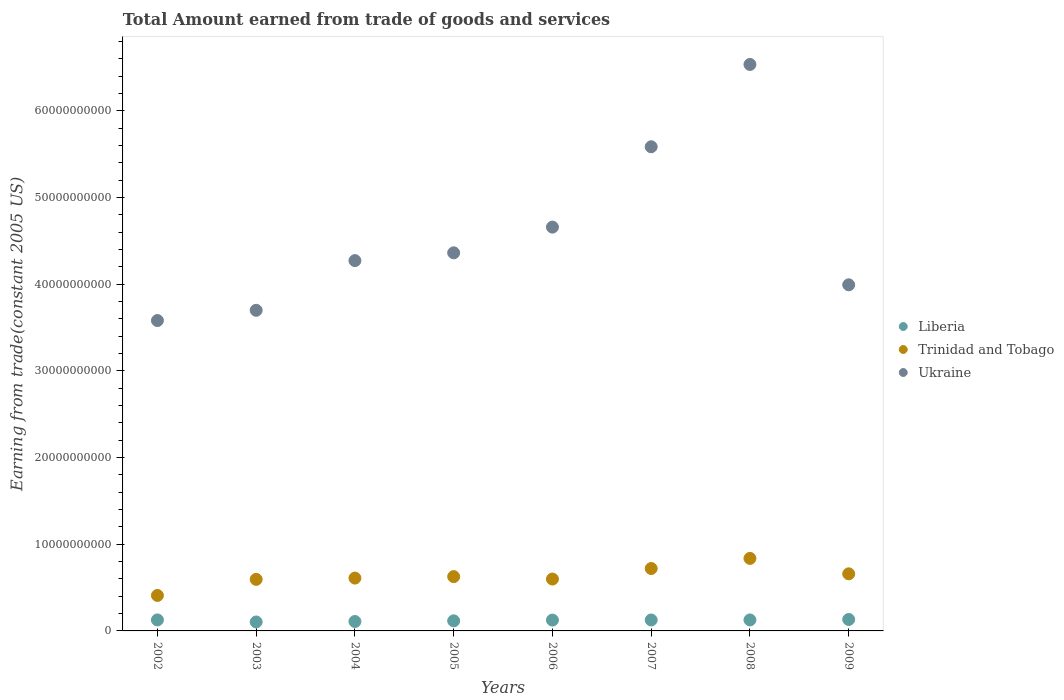Is the number of dotlines equal to the number of legend labels?
Keep it short and to the point. Yes. What is the total amount earned by trading goods and services in Trinidad and Tobago in 2009?
Offer a very short reply. 6.59e+09. Across all years, what is the maximum total amount earned by trading goods and services in Liberia?
Provide a short and direct response. 1.32e+09. Across all years, what is the minimum total amount earned by trading goods and services in Liberia?
Your answer should be compact. 1.03e+09. In which year was the total amount earned by trading goods and services in Liberia maximum?
Offer a terse response. 2009. In which year was the total amount earned by trading goods and services in Liberia minimum?
Ensure brevity in your answer.  2003. What is the total total amount earned by trading goods and services in Trinidad and Tobago in the graph?
Your answer should be very brief. 5.05e+1. What is the difference between the total amount earned by trading goods and services in Trinidad and Tobago in 2005 and that in 2007?
Your response must be concise. -9.33e+08. What is the difference between the total amount earned by trading goods and services in Trinidad and Tobago in 2005 and the total amount earned by trading goods and services in Liberia in 2009?
Ensure brevity in your answer.  4.94e+09. What is the average total amount earned by trading goods and services in Liberia per year?
Provide a short and direct response. 1.21e+09. In the year 2009, what is the difference between the total amount earned by trading goods and services in Ukraine and total amount earned by trading goods and services in Liberia?
Give a very brief answer. 3.86e+1. In how many years, is the total amount earned by trading goods and services in Liberia greater than 64000000000 US$?
Give a very brief answer. 0. What is the ratio of the total amount earned by trading goods and services in Trinidad and Tobago in 2006 to that in 2009?
Provide a short and direct response. 0.91. What is the difference between the highest and the second highest total amount earned by trading goods and services in Liberia?
Your response must be concise. 5.17e+07. What is the difference between the highest and the lowest total amount earned by trading goods and services in Liberia?
Make the answer very short. 2.88e+08. Does the total amount earned by trading goods and services in Ukraine monotonically increase over the years?
Provide a short and direct response. No. Is the total amount earned by trading goods and services in Trinidad and Tobago strictly greater than the total amount earned by trading goods and services in Liberia over the years?
Ensure brevity in your answer.  Yes. How many dotlines are there?
Provide a succinct answer. 3. Are the values on the major ticks of Y-axis written in scientific E-notation?
Ensure brevity in your answer.  No. Where does the legend appear in the graph?
Your answer should be very brief. Center right. How many legend labels are there?
Give a very brief answer. 3. How are the legend labels stacked?
Your response must be concise. Vertical. What is the title of the graph?
Your answer should be very brief. Total Amount earned from trade of goods and services. Does "Latin America(all income levels)" appear as one of the legend labels in the graph?
Give a very brief answer. No. What is the label or title of the X-axis?
Ensure brevity in your answer.  Years. What is the label or title of the Y-axis?
Offer a terse response. Earning from trade(constant 2005 US). What is the Earning from trade(constant 2005 US) of Liberia in 2002?
Make the answer very short. 1.27e+09. What is the Earning from trade(constant 2005 US) in Trinidad and Tobago in 2002?
Your response must be concise. 4.09e+09. What is the Earning from trade(constant 2005 US) of Ukraine in 2002?
Your answer should be very brief. 3.58e+1. What is the Earning from trade(constant 2005 US) of Liberia in 2003?
Your response must be concise. 1.03e+09. What is the Earning from trade(constant 2005 US) of Trinidad and Tobago in 2003?
Keep it short and to the point. 5.95e+09. What is the Earning from trade(constant 2005 US) in Ukraine in 2003?
Keep it short and to the point. 3.70e+1. What is the Earning from trade(constant 2005 US) of Liberia in 2004?
Your answer should be compact. 1.09e+09. What is the Earning from trade(constant 2005 US) of Trinidad and Tobago in 2004?
Give a very brief answer. 6.10e+09. What is the Earning from trade(constant 2005 US) in Ukraine in 2004?
Make the answer very short. 4.27e+1. What is the Earning from trade(constant 2005 US) in Liberia in 2005?
Your answer should be compact. 1.16e+09. What is the Earning from trade(constant 2005 US) of Trinidad and Tobago in 2005?
Provide a succinct answer. 6.27e+09. What is the Earning from trade(constant 2005 US) in Ukraine in 2005?
Your response must be concise. 4.36e+1. What is the Earning from trade(constant 2005 US) of Liberia in 2006?
Your answer should be very brief. 1.25e+09. What is the Earning from trade(constant 2005 US) in Trinidad and Tobago in 2006?
Ensure brevity in your answer.  5.99e+09. What is the Earning from trade(constant 2005 US) of Ukraine in 2006?
Your response must be concise. 4.66e+1. What is the Earning from trade(constant 2005 US) in Liberia in 2007?
Your answer should be very brief. 1.26e+09. What is the Earning from trade(constant 2005 US) in Trinidad and Tobago in 2007?
Keep it short and to the point. 7.20e+09. What is the Earning from trade(constant 2005 US) of Ukraine in 2007?
Provide a short and direct response. 5.59e+1. What is the Earning from trade(constant 2005 US) of Liberia in 2008?
Offer a terse response. 1.27e+09. What is the Earning from trade(constant 2005 US) of Trinidad and Tobago in 2008?
Keep it short and to the point. 8.37e+09. What is the Earning from trade(constant 2005 US) in Ukraine in 2008?
Your answer should be compact. 6.54e+1. What is the Earning from trade(constant 2005 US) in Liberia in 2009?
Offer a terse response. 1.32e+09. What is the Earning from trade(constant 2005 US) in Trinidad and Tobago in 2009?
Provide a succinct answer. 6.59e+09. What is the Earning from trade(constant 2005 US) of Ukraine in 2009?
Keep it short and to the point. 3.99e+1. Across all years, what is the maximum Earning from trade(constant 2005 US) of Liberia?
Offer a very short reply. 1.32e+09. Across all years, what is the maximum Earning from trade(constant 2005 US) in Trinidad and Tobago?
Your answer should be compact. 8.37e+09. Across all years, what is the maximum Earning from trade(constant 2005 US) in Ukraine?
Your answer should be very brief. 6.54e+1. Across all years, what is the minimum Earning from trade(constant 2005 US) in Liberia?
Your answer should be compact. 1.03e+09. Across all years, what is the minimum Earning from trade(constant 2005 US) in Trinidad and Tobago?
Offer a very short reply. 4.09e+09. Across all years, what is the minimum Earning from trade(constant 2005 US) of Ukraine?
Your answer should be compact. 3.58e+1. What is the total Earning from trade(constant 2005 US) of Liberia in the graph?
Ensure brevity in your answer.  9.65e+09. What is the total Earning from trade(constant 2005 US) in Trinidad and Tobago in the graph?
Ensure brevity in your answer.  5.05e+1. What is the total Earning from trade(constant 2005 US) in Ukraine in the graph?
Keep it short and to the point. 3.67e+11. What is the difference between the Earning from trade(constant 2005 US) in Liberia in 2002 and that in 2003?
Make the answer very short. 2.36e+08. What is the difference between the Earning from trade(constant 2005 US) of Trinidad and Tobago in 2002 and that in 2003?
Offer a terse response. -1.86e+09. What is the difference between the Earning from trade(constant 2005 US) of Ukraine in 2002 and that in 2003?
Offer a very short reply. -1.18e+09. What is the difference between the Earning from trade(constant 2005 US) in Liberia in 2002 and that in 2004?
Provide a short and direct response. 1.83e+08. What is the difference between the Earning from trade(constant 2005 US) of Trinidad and Tobago in 2002 and that in 2004?
Offer a very short reply. -2.00e+09. What is the difference between the Earning from trade(constant 2005 US) in Ukraine in 2002 and that in 2004?
Your answer should be very brief. -6.92e+09. What is the difference between the Earning from trade(constant 2005 US) of Liberia in 2002 and that in 2005?
Provide a short and direct response. 1.07e+08. What is the difference between the Earning from trade(constant 2005 US) in Trinidad and Tobago in 2002 and that in 2005?
Provide a short and direct response. -2.17e+09. What is the difference between the Earning from trade(constant 2005 US) in Ukraine in 2002 and that in 2005?
Provide a short and direct response. -7.81e+09. What is the difference between the Earning from trade(constant 2005 US) of Liberia in 2002 and that in 2006?
Your answer should be compact. 1.92e+07. What is the difference between the Earning from trade(constant 2005 US) in Trinidad and Tobago in 2002 and that in 2006?
Keep it short and to the point. -1.89e+09. What is the difference between the Earning from trade(constant 2005 US) in Ukraine in 2002 and that in 2006?
Give a very brief answer. -1.08e+1. What is the difference between the Earning from trade(constant 2005 US) of Liberia in 2002 and that in 2007?
Your response must be concise. 6.13e+06. What is the difference between the Earning from trade(constant 2005 US) in Trinidad and Tobago in 2002 and that in 2007?
Ensure brevity in your answer.  -3.11e+09. What is the difference between the Earning from trade(constant 2005 US) of Ukraine in 2002 and that in 2007?
Offer a terse response. -2.01e+1. What is the difference between the Earning from trade(constant 2005 US) of Liberia in 2002 and that in 2008?
Your answer should be very brief. 1.72e+06. What is the difference between the Earning from trade(constant 2005 US) of Trinidad and Tobago in 2002 and that in 2008?
Your answer should be very brief. -4.28e+09. What is the difference between the Earning from trade(constant 2005 US) in Ukraine in 2002 and that in 2008?
Make the answer very short. -2.95e+1. What is the difference between the Earning from trade(constant 2005 US) of Liberia in 2002 and that in 2009?
Give a very brief answer. -5.17e+07. What is the difference between the Earning from trade(constant 2005 US) in Trinidad and Tobago in 2002 and that in 2009?
Keep it short and to the point. -2.49e+09. What is the difference between the Earning from trade(constant 2005 US) in Ukraine in 2002 and that in 2009?
Ensure brevity in your answer.  -4.12e+09. What is the difference between the Earning from trade(constant 2005 US) in Liberia in 2003 and that in 2004?
Keep it short and to the point. -5.36e+07. What is the difference between the Earning from trade(constant 2005 US) of Trinidad and Tobago in 2003 and that in 2004?
Your answer should be compact. -1.48e+08. What is the difference between the Earning from trade(constant 2005 US) of Ukraine in 2003 and that in 2004?
Offer a terse response. -5.73e+09. What is the difference between the Earning from trade(constant 2005 US) in Liberia in 2003 and that in 2005?
Your answer should be compact. -1.29e+08. What is the difference between the Earning from trade(constant 2005 US) of Trinidad and Tobago in 2003 and that in 2005?
Your answer should be compact. -3.18e+08. What is the difference between the Earning from trade(constant 2005 US) in Ukraine in 2003 and that in 2005?
Offer a terse response. -6.63e+09. What is the difference between the Earning from trade(constant 2005 US) in Liberia in 2003 and that in 2006?
Provide a short and direct response. -2.17e+08. What is the difference between the Earning from trade(constant 2005 US) of Trinidad and Tobago in 2003 and that in 2006?
Your answer should be compact. -3.75e+07. What is the difference between the Earning from trade(constant 2005 US) of Ukraine in 2003 and that in 2006?
Offer a very short reply. -9.60e+09. What is the difference between the Earning from trade(constant 2005 US) of Liberia in 2003 and that in 2007?
Your response must be concise. -2.30e+08. What is the difference between the Earning from trade(constant 2005 US) of Trinidad and Tobago in 2003 and that in 2007?
Your answer should be compact. -1.25e+09. What is the difference between the Earning from trade(constant 2005 US) of Ukraine in 2003 and that in 2007?
Keep it short and to the point. -1.89e+1. What is the difference between the Earning from trade(constant 2005 US) of Liberia in 2003 and that in 2008?
Provide a succinct answer. -2.34e+08. What is the difference between the Earning from trade(constant 2005 US) of Trinidad and Tobago in 2003 and that in 2008?
Offer a terse response. -2.42e+09. What is the difference between the Earning from trade(constant 2005 US) in Ukraine in 2003 and that in 2008?
Ensure brevity in your answer.  -2.84e+1. What is the difference between the Earning from trade(constant 2005 US) in Liberia in 2003 and that in 2009?
Offer a terse response. -2.88e+08. What is the difference between the Earning from trade(constant 2005 US) of Trinidad and Tobago in 2003 and that in 2009?
Offer a terse response. -6.39e+08. What is the difference between the Earning from trade(constant 2005 US) in Ukraine in 2003 and that in 2009?
Offer a very short reply. -2.94e+09. What is the difference between the Earning from trade(constant 2005 US) in Liberia in 2004 and that in 2005?
Provide a short and direct response. -7.54e+07. What is the difference between the Earning from trade(constant 2005 US) of Trinidad and Tobago in 2004 and that in 2005?
Offer a terse response. -1.70e+08. What is the difference between the Earning from trade(constant 2005 US) of Ukraine in 2004 and that in 2005?
Offer a very short reply. -8.97e+08. What is the difference between the Earning from trade(constant 2005 US) of Liberia in 2004 and that in 2006?
Make the answer very short. -1.63e+08. What is the difference between the Earning from trade(constant 2005 US) in Trinidad and Tobago in 2004 and that in 2006?
Your answer should be compact. 1.11e+08. What is the difference between the Earning from trade(constant 2005 US) of Ukraine in 2004 and that in 2006?
Provide a succinct answer. -3.86e+09. What is the difference between the Earning from trade(constant 2005 US) in Liberia in 2004 and that in 2007?
Offer a very short reply. -1.76e+08. What is the difference between the Earning from trade(constant 2005 US) in Trinidad and Tobago in 2004 and that in 2007?
Offer a terse response. -1.10e+09. What is the difference between the Earning from trade(constant 2005 US) of Ukraine in 2004 and that in 2007?
Provide a succinct answer. -1.31e+1. What is the difference between the Earning from trade(constant 2005 US) of Liberia in 2004 and that in 2008?
Give a very brief answer. -1.81e+08. What is the difference between the Earning from trade(constant 2005 US) of Trinidad and Tobago in 2004 and that in 2008?
Provide a short and direct response. -2.27e+09. What is the difference between the Earning from trade(constant 2005 US) in Ukraine in 2004 and that in 2008?
Offer a very short reply. -2.26e+1. What is the difference between the Earning from trade(constant 2005 US) in Liberia in 2004 and that in 2009?
Keep it short and to the point. -2.34e+08. What is the difference between the Earning from trade(constant 2005 US) in Trinidad and Tobago in 2004 and that in 2009?
Provide a succinct answer. -4.90e+08. What is the difference between the Earning from trade(constant 2005 US) in Ukraine in 2004 and that in 2009?
Your response must be concise. 2.79e+09. What is the difference between the Earning from trade(constant 2005 US) in Liberia in 2005 and that in 2006?
Give a very brief answer. -8.80e+07. What is the difference between the Earning from trade(constant 2005 US) of Trinidad and Tobago in 2005 and that in 2006?
Your response must be concise. 2.81e+08. What is the difference between the Earning from trade(constant 2005 US) in Ukraine in 2005 and that in 2006?
Provide a succinct answer. -2.97e+09. What is the difference between the Earning from trade(constant 2005 US) in Liberia in 2005 and that in 2007?
Make the answer very short. -1.01e+08. What is the difference between the Earning from trade(constant 2005 US) in Trinidad and Tobago in 2005 and that in 2007?
Provide a succinct answer. -9.33e+08. What is the difference between the Earning from trade(constant 2005 US) in Ukraine in 2005 and that in 2007?
Offer a terse response. -1.22e+1. What is the difference between the Earning from trade(constant 2005 US) of Liberia in 2005 and that in 2008?
Make the answer very short. -1.06e+08. What is the difference between the Earning from trade(constant 2005 US) in Trinidad and Tobago in 2005 and that in 2008?
Keep it short and to the point. -2.10e+09. What is the difference between the Earning from trade(constant 2005 US) of Ukraine in 2005 and that in 2008?
Make the answer very short. -2.17e+1. What is the difference between the Earning from trade(constant 2005 US) in Liberia in 2005 and that in 2009?
Offer a very short reply. -1.59e+08. What is the difference between the Earning from trade(constant 2005 US) of Trinidad and Tobago in 2005 and that in 2009?
Offer a terse response. -3.20e+08. What is the difference between the Earning from trade(constant 2005 US) in Ukraine in 2005 and that in 2009?
Keep it short and to the point. 3.69e+09. What is the difference between the Earning from trade(constant 2005 US) in Liberia in 2006 and that in 2007?
Provide a succinct answer. -1.31e+07. What is the difference between the Earning from trade(constant 2005 US) of Trinidad and Tobago in 2006 and that in 2007?
Your response must be concise. -1.21e+09. What is the difference between the Earning from trade(constant 2005 US) of Ukraine in 2006 and that in 2007?
Give a very brief answer. -9.27e+09. What is the difference between the Earning from trade(constant 2005 US) of Liberia in 2006 and that in 2008?
Ensure brevity in your answer.  -1.75e+07. What is the difference between the Earning from trade(constant 2005 US) of Trinidad and Tobago in 2006 and that in 2008?
Your answer should be very brief. -2.38e+09. What is the difference between the Earning from trade(constant 2005 US) of Ukraine in 2006 and that in 2008?
Provide a succinct answer. -1.88e+1. What is the difference between the Earning from trade(constant 2005 US) in Liberia in 2006 and that in 2009?
Your response must be concise. -7.09e+07. What is the difference between the Earning from trade(constant 2005 US) in Trinidad and Tobago in 2006 and that in 2009?
Provide a short and direct response. -6.01e+08. What is the difference between the Earning from trade(constant 2005 US) of Ukraine in 2006 and that in 2009?
Your answer should be compact. 6.66e+09. What is the difference between the Earning from trade(constant 2005 US) of Liberia in 2007 and that in 2008?
Make the answer very short. -4.40e+06. What is the difference between the Earning from trade(constant 2005 US) in Trinidad and Tobago in 2007 and that in 2008?
Provide a short and direct response. -1.17e+09. What is the difference between the Earning from trade(constant 2005 US) of Ukraine in 2007 and that in 2008?
Give a very brief answer. -9.50e+09. What is the difference between the Earning from trade(constant 2005 US) of Liberia in 2007 and that in 2009?
Give a very brief answer. -5.79e+07. What is the difference between the Earning from trade(constant 2005 US) in Trinidad and Tobago in 2007 and that in 2009?
Provide a succinct answer. 6.12e+08. What is the difference between the Earning from trade(constant 2005 US) of Ukraine in 2007 and that in 2009?
Your answer should be compact. 1.59e+1. What is the difference between the Earning from trade(constant 2005 US) of Liberia in 2008 and that in 2009?
Your answer should be very brief. -5.35e+07. What is the difference between the Earning from trade(constant 2005 US) in Trinidad and Tobago in 2008 and that in 2009?
Provide a short and direct response. 1.78e+09. What is the difference between the Earning from trade(constant 2005 US) of Ukraine in 2008 and that in 2009?
Your response must be concise. 2.54e+1. What is the difference between the Earning from trade(constant 2005 US) in Liberia in 2002 and the Earning from trade(constant 2005 US) in Trinidad and Tobago in 2003?
Make the answer very short. -4.68e+09. What is the difference between the Earning from trade(constant 2005 US) in Liberia in 2002 and the Earning from trade(constant 2005 US) in Ukraine in 2003?
Offer a very short reply. -3.57e+1. What is the difference between the Earning from trade(constant 2005 US) in Trinidad and Tobago in 2002 and the Earning from trade(constant 2005 US) in Ukraine in 2003?
Your answer should be compact. -3.29e+1. What is the difference between the Earning from trade(constant 2005 US) in Liberia in 2002 and the Earning from trade(constant 2005 US) in Trinidad and Tobago in 2004?
Make the answer very short. -4.83e+09. What is the difference between the Earning from trade(constant 2005 US) in Liberia in 2002 and the Earning from trade(constant 2005 US) in Ukraine in 2004?
Offer a terse response. -4.15e+1. What is the difference between the Earning from trade(constant 2005 US) of Trinidad and Tobago in 2002 and the Earning from trade(constant 2005 US) of Ukraine in 2004?
Provide a succinct answer. -3.86e+1. What is the difference between the Earning from trade(constant 2005 US) in Liberia in 2002 and the Earning from trade(constant 2005 US) in Trinidad and Tobago in 2005?
Make the answer very short. -5.00e+09. What is the difference between the Earning from trade(constant 2005 US) in Liberia in 2002 and the Earning from trade(constant 2005 US) in Ukraine in 2005?
Offer a terse response. -4.24e+1. What is the difference between the Earning from trade(constant 2005 US) in Trinidad and Tobago in 2002 and the Earning from trade(constant 2005 US) in Ukraine in 2005?
Your response must be concise. -3.95e+1. What is the difference between the Earning from trade(constant 2005 US) of Liberia in 2002 and the Earning from trade(constant 2005 US) of Trinidad and Tobago in 2006?
Ensure brevity in your answer.  -4.72e+09. What is the difference between the Earning from trade(constant 2005 US) in Liberia in 2002 and the Earning from trade(constant 2005 US) in Ukraine in 2006?
Offer a terse response. -4.53e+1. What is the difference between the Earning from trade(constant 2005 US) in Trinidad and Tobago in 2002 and the Earning from trade(constant 2005 US) in Ukraine in 2006?
Your answer should be compact. -4.25e+1. What is the difference between the Earning from trade(constant 2005 US) of Liberia in 2002 and the Earning from trade(constant 2005 US) of Trinidad and Tobago in 2007?
Your response must be concise. -5.93e+09. What is the difference between the Earning from trade(constant 2005 US) of Liberia in 2002 and the Earning from trade(constant 2005 US) of Ukraine in 2007?
Provide a succinct answer. -5.46e+1. What is the difference between the Earning from trade(constant 2005 US) in Trinidad and Tobago in 2002 and the Earning from trade(constant 2005 US) in Ukraine in 2007?
Keep it short and to the point. -5.18e+1. What is the difference between the Earning from trade(constant 2005 US) in Liberia in 2002 and the Earning from trade(constant 2005 US) in Trinidad and Tobago in 2008?
Your answer should be compact. -7.10e+09. What is the difference between the Earning from trade(constant 2005 US) in Liberia in 2002 and the Earning from trade(constant 2005 US) in Ukraine in 2008?
Provide a short and direct response. -6.41e+1. What is the difference between the Earning from trade(constant 2005 US) in Trinidad and Tobago in 2002 and the Earning from trade(constant 2005 US) in Ukraine in 2008?
Provide a succinct answer. -6.13e+1. What is the difference between the Earning from trade(constant 2005 US) in Liberia in 2002 and the Earning from trade(constant 2005 US) in Trinidad and Tobago in 2009?
Your response must be concise. -5.32e+09. What is the difference between the Earning from trade(constant 2005 US) in Liberia in 2002 and the Earning from trade(constant 2005 US) in Ukraine in 2009?
Give a very brief answer. -3.87e+1. What is the difference between the Earning from trade(constant 2005 US) in Trinidad and Tobago in 2002 and the Earning from trade(constant 2005 US) in Ukraine in 2009?
Ensure brevity in your answer.  -3.58e+1. What is the difference between the Earning from trade(constant 2005 US) in Liberia in 2003 and the Earning from trade(constant 2005 US) in Trinidad and Tobago in 2004?
Your answer should be very brief. -5.06e+09. What is the difference between the Earning from trade(constant 2005 US) of Liberia in 2003 and the Earning from trade(constant 2005 US) of Ukraine in 2004?
Your answer should be compact. -4.17e+1. What is the difference between the Earning from trade(constant 2005 US) of Trinidad and Tobago in 2003 and the Earning from trade(constant 2005 US) of Ukraine in 2004?
Provide a short and direct response. -3.68e+1. What is the difference between the Earning from trade(constant 2005 US) of Liberia in 2003 and the Earning from trade(constant 2005 US) of Trinidad and Tobago in 2005?
Keep it short and to the point. -5.23e+09. What is the difference between the Earning from trade(constant 2005 US) in Liberia in 2003 and the Earning from trade(constant 2005 US) in Ukraine in 2005?
Ensure brevity in your answer.  -4.26e+1. What is the difference between the Earning from trade(constant 2005 US) in Trinidad and Tobago in 2003 and the Earning from trade(constant 2005 US) in Ukraine in 2005?
Provide a short and direct response. -3.77e+1. What is the difference between the Earning from trade(constant 2005 US) of Liberia in 2003 and the Earning from trade(constant 2005 US) of Trinidad and Tobago in 2006?
Offer a terse response. -4.95e+09. What is the difference between the Earning from trade(constant 2005 US) of Liberia in 2003 and the Earning from trade(constant 2005 US) of Ukraine in 2006?
Make the answer very short. -4.56e+1. What is the difference between the Earning from trade(constant 2005 US) of Trinidad and Tobago in 2003 and the Earning from trade(constant 2005 US) of Ukraine in 2006?
Give a very brief answer. -4.06e+1. What is the difference between the Earning from trade(constant 2005 US) in Liberia in 2003 and the Earning from trade(constant 2005 US) in Trinidad and Tobago in 2007?
Provide a short and direct response. -6.17e+09. What is the difference between the Earning from trade(constant 2005 US) of Liberia in 2003 and the Earning from trade(constant 2005 US) of Ukraine in 2007?
Offer a very short reply. -5.48e+1. What is the difference between the Earning from trade(constant 2005 US) of Trinidad and Tobago in 2003 and the Earning from trade(constant 2005 US) of Ukraine in 2007?
Make the answer very short. -4.99e+1. What is the difference between the Earning from trade(constant 2005 US) in Liberia in 2003 and the Earning from trade(constant 2005 US) in Trinidad and Tobago in 2008?
Provide a succinct answer. -7.33e+09. What is the difference between the Earning from trade(constant 2005 US) of Liberia in 2003 and the Earning from trade(constant 2005 US) of Ukraine in 2008?
Offer a terse response. -6.43e+1. What is the difference between the Earning from trade(constant 2005 US) in Trinidad and Tobago in 2003 and the Earning from trade(constant 2005 US) in Ukraine in 2008?
Ensure brevity in your answer.  -5.94e+1. What is the difference between the Earning from trade(constant 2005 US) in Liberia in 2003 and the Earning from trade(constant 2005 US) in Trinidad and Tobago in 2009?
Offer a terse response. -5.55e+09. What is the difference between the Earning from trade(constant 2005 US) in Liberia in 2003 and the Earning from trade(constant 2005 US) in Ukraine in 2009?
Ensure brevity in your answer.  -3.89e+1. What is the difference between the Earning from trade(constant 2005 US) of Trinidad and Tobago in 2003 and the Earning from trade(constant 2005 US) of Ukraine in 2009?
Ensure brevity in your answer.  -3.40e+1. What is the difference between the Earning from trade(constant 2005 US) in Liberia in 2004 and the Earning from trade(constant 2005 US) in Trinidad and Tobago in 2005?
Your answer should be very brief. -5.18e+09. What is the difference between the Earning from trade(constant 2005 US) in Liberia in 2004 and the Earning from trade(constant 2005 US) in Ukraine in 2005?
Make the answer very short. -4.25e+1. What is the difference between the Earning from trade(constant 2005 US) in Trinidad and Tobago in 2004 and the Earning from trade(constant 2005 US) in Ukraine in 2005?
Keep it short and to the point. -3.75e+1. What is the difference between the Earning from trade(constant 2005 US) of Liberia in 2004 and the Earning from trade(constant 2005 US) of Trinidad and Tobago in 2006?
Offer a terse response. -4.90e+09. What is the difference between the Earning from trade(constant 2005 US) of Liberia in 2004 and the Earning from trade(constant 2005 US) of Ukraine in 2006?
Your response must be concise. -4.55e+1. What is the difference between the Earning from trade(constant 2005 US) in Trinidad and Tobago in 2004 and the Earning from trade(constant 2005 US) in Ukraine in 2006?
Your answer should be very brief. -4.05e+1. What is the difference between the Earning from trade(constant 2005 US) of Liberia in 2004 and the Earning from trade(constant 2005 US) of Trinidad and Tobago in 2007?
Provide a succinct answer. -6.11e+09. What is the difference between the Earning from trade(constant 2005 US) in Liberia in 2004 and the Earning from trade(constant 2005 US) in Ukraine in 2007?
Provide a succinct answer. -5.48e+1. What is the difference between the Earning from trade(constant 2005 US) in Trinidad and Tobago in 2004 and the Earning from trade(constant 2005 US) in Ukraine in 2007?
Your response must be concise. -4.98e+1. What is the difference between the Earning from trade(constant 2005 US) of Liberia in 2004 and the Earning from trade(constant 2005 US) of Trinidad and Tobago in 2008?
Provide a succinct answer. -7.28e+09. What is the difference between the Earning from trade(constant 2005 US) of Liberia in 2004 and the Earning from trade(constant 2005 US) of Ukraine in 2008?
Make the answer very short. -6.43e+1. What is the difference between the Earning from trade(constant 2005 US) in Trinidad and Tobago in 2004 and the Earning from trade(constant 2005 US) in Ukraine in 2008?
Make the answer very short. -5.93e+1. What is the difference between the Earning from trade(constant 2005 US) in Liberia in 2004 and the Earning from trade(constant 2005 US) in Trinidad and Tobago in 2009?
Make the answer very short. -5.50e+09. What is the difference between the Earning from trade(constant 2005 US) of Liberia in 2004 and the Earning from trade(constant 2005 US) of Ukraine in 2009?
Your response must be concise. -3.88e+1. What is the difference between the Earning from trade(constant 2005 US) of Trinidad and Tobago in 2004 and the Earning from trade(constant 2005 US) of Ukraine in 2009?
Your response must be concise. -3.38e+1. What is the difference between the Earning from trade(constant 2005 US) in Liberia in 2005 and the Earning from trade(constant 2005 US) in Trinidad and Tobago in 2006?
Keep it short and to the point. -4.82e+09. What is the difference between the Earning from trade(constant 2005 US) in Liberia in 2005 and the Earning from trade(constant 2005 US) in Ukraine in 2006?
Your response must be concise. -4.54e+1. What is the difference between the Earning from trade(constant 2005 US) of Trinidad and Tobago in 2005 and the Earning from trade(constant 2005 US) of Ukraine in 2006?
Your answer should be very brief. -4.03e+1. What is the difference between the Earning from trade(constant 2005 US) in Liberia in 2005 and the Earning from trade(constant 2005 US) in Trinidad and Tobago in 2007?
Your response must be concise. -6.04e+09. What is the difference between the Earning from trade(constant 2005 US) of Liberia in 2005 and the Earning from trade(constant 2005 US) of Ukraine in 2007?
Offer a terse response. -5.47e+1. What is the difference between the Earning from trade(constant 2005 US) in Trinidad and Tobago in 2005 and the Earning from trade(constant 2005 US) in Ukraine in 2007?
Offer a terse response. -4.96e+1. What is the difference between the Earning from trade(constant 2005 US) of Liberia in 2005 and the Earning from trade(constant 2005 US) of Trinidad and Tobago in 2008?
Your answer should be very brief. -7.21e+09. What is the difference between the Earning from trade(constant 2005 US) in Liberia in 2005 and the Earning from trade(constant 2005 US) in Ukraine in 2008?
Offer a very short reply. -6.42e+1. What is the difference between the Earning from trade(constant 2005 US) in Trinidad and Tobago in 2005 and the Earning from trade(constant 2005 US) in Ukraine in 2008?
Your answer should be very brief. -5.91e+1. What is the difference between the Earning from trade(constant 2005 US) of Liberia in 2005 and the Earning from trade(constant 2005 US) of Trinidad and Tobago in 2009?
Provide a succinct answer. -5.42e+09. What is the difference between the Earning from trade(constant 2005 US) in Liberia in 2005 and the Earning from trade(constant 2005 US) in Ukraine in 2009?
Make the answer very short. -3.88e+1. What is the difference between the Earning from trade(constant 2005 US) of Trinidad and Tobago in 2005 and the Earning from trade(constant 2005 US) of Ukraine in 2009?
Provide a short and direct response. -3.37e+1. What is the difference between the Earning from trade(constant 2005 US) in Liberia in 2006 and the Earning from trade(constant 2005 US) in Trinidad and Tobago in 2007?
Make the answer very short. -5.95e+09. What is the difference between the Earning from trade(constant 2005 US) in Liberia in 2006 and the Earning from trade(constant 2005 US) in Ukraine in 2007?
Make the answer very short. -5.46e+1. What is the difference between the Earning from trade(constant 2005 US) in Trinidad and Tobago in 2006 and the Earning from trade(constant 2005 US) in Ukraine in 2007?
Your response must be concise. -4.99e+1. What is the difference between the Earning from trade(constant 2005 US) in Liberia in 2006 and the Earning from trade(constant 2005 US) in Trinidad and Tobago in 2008?
Ensure brevity in your answer.  -7.12e+09. What is the difference between the Earning from trade(constant 2005 US) in Liberia in 2006 and the Earning from trade(constant 2005 US) in Ukraine in 2008?
Make the answer very short. -6.41e+1. What is the difference between the Earning from trade(constant 2005 US) of Trinidad and Tobago in 2006 and the Earning from trade(constant 2005 US) of Ukraine in 2008?
Provide a short and direct response. -5.94e+1. What is the difference between the Earning from trade(constant 2005 US) of Liberia in 2006 and the Earning from trade(constant 2005 US) of Trinidad and Tobago in 2009?
Provide a succinct answer. -5.34e+09. What is the difference between the Earning from trade(constant 2005 US) of Liberia in 2006 and the Earning from trade(constant 2005 US) of Ukraine in 2009?
Your answer should be compact. -3.87e+1. What is the difference between the Earning from trade(constant 2005 US) of Trinidad and Tobago in 2006 and the Earning from trade(constant 2005 US) of Ukraine in 2009?
Ensure brevity in your answer.  -3.39e+1. What is the difference between the Earning from trade(constant 2005 US) in Liberia in 2007 and the Earning from trade(constant 2005 US) in Trinidad and Tobago in 2008?
Your answer should be very brief. -7.10e+09. What is the difference between the Earning from trade(constant 2005 US) of Liberia in 2007 and the Earning from trade(constant 2005 US) of Ukraine in 2008?
Give a very brief answer. -6.41e+1. What is the difference between the Earning from trade(constant 2005 US) of Trinidad and Tobago in 2007 and the Earning from trade(constant 2005 US) of Ukraine in 2008?
Your answer should be very brief. -5.82e+1. What is the difference between the Earning from trade(constant 2005 US) of Liberia in 2007 and the Earning from trade(constant 2005 US) of Trinidad and Tobago in 2009?
Provide a short and direct response. -5.32e+09. What is the difference between the Earning from trade(constant 2005 US) in Liberia in 2007 and the Earning from trade(constant 2005 US) in Ukraine in 2009?
Your response must be concise. -3.87e+1. What is the difference between the Earning from trade(constant 2005 US) in Trinidad and Tobago in 2007 and the Earning from trade(constant 2005 US) in Ukraine in 2009?
Your answer should be compact. -3.27e+1. What is the difference between the Earning from trade(constant 2005 US) of Liberia in 2008 and the Earning from trade(constant 2005 US) of Trinidad and Tobago in 2009?
Ensure brevity in your answer.  -5.32e+09. What is the difference between the Earning from trade(constant 2005 US) of Liberia in 2008 and the Earning from trade(constant 2005 US) of Ukraine in 2009?
Your answer should be compact. -3.87e+1. What is the difference between the Earning from trade(constant 2005 US) of Trinidad and Tobago in 2008 and the Earning from trade(constant 2005 US) of Ukraine in 2009?
Make the answer very short. -3.16e+1. What is the average Earning from trade(constant 2005 US) in Liberia per year?
Keep it short and to the point. 1.21e+09. What is the average Earning from trade(constant 2005 US) in Trinidad and Tobago per year?
Make the answer very short. 6.32e+09. What is the average Earning from trade(constant 2005 US) in Ukraine per year?
Give a very brief answer. 4.59e+1. In the year 2002, what is the difference between the Earning from trade(constant 2005 US) in Liberia and Earning from trade(constant 2005 US) in Trinidad and Tobago?
Ensure brevity in your answer.  -2.82e+09. In the year 2002, what is the difference between the Earning from trade(constant 2005 US) in Liberia and Earning from trade(constant 2005 US) in Ukraine?
Provide a short and direct response. -3.45e+1. In the year 2002, what is the difference between the Earning from trade(constant 2005 US) of Trinidad and Tobago and Earning from trade(constant 2005 US) of Ukraine?
Provide a short and direct response. -3.17e+1. In the year 2003, what is the difference between the Earning from trade(constant 2005 US) in Liberia and Earning from trade(constant 2005 US) in Trinidad and Tobago?
Keep it short and to the point. -4.91e+09. In the year 2003, what is the difference between the Earning from trade(constant 2005 US) in Liberia and Earning from trade(constant 2005 US) in Ukraine?
Your answer should be very brief. -3.60e+1. In the year 2003, what is the difference between the Earning from trade(constant 2005 US) in Trinidad and Tobago and Earning from trade(constant 2005 US) in Ukraine?
Provide a succinct answer. -3.10e+1. In the year 2004, what is the difference between the Earning from trade(constant 2005 US) of Liberia and Earning from trade(constant 2005 US) of Trinidad and Tobago?
Ensure brevity in your answer.  -5.01e+09. In the year 2004, what is the difference between the Earning from trade(constant 2005 US) of Liberia and Earning from trade(constant 2005 US) of Ukraine?
Offer a very short reply. -4.16e+1. In the year 2004, what is the difference between the Earning from trade(constant 2005 US) in Trinidad and Tobago and Earning from trade(constant 2005 US) in Ukraine?
Ensure brevity in your answer.  -3.66e+1. In the year 2005, what is the difference between the Earning from trade(constant 2005 US) in Liberia and Earning from trade(constant 2005 US) in Trinidad and Tobago?
Your response must be concise. -5.10e+09. In the year 2005, what is the difference between the Earning from trade(constant 2005 US) in Liberia and Earning from trade(constant 2005 US) in Ukraine?
Your response must be concise. -4.25e+1. In the year 2005, what is the difference between the Earning from trade(constant 2005 US) in Trinidad and Tobago and Earning from trade(constant 2005 US) in Ukraine?
Provide a short and direct response. -3.74e+1. In the year 2006, what is the difference between the Earning from trade(constant 2005 US) of Liberia and Earning from trade(constant 2005 US) of Trinidad and Tobago?
Give a very brief answer. -4.74e+09. In the year 2006, what is the difference between the Earning from trade(constant 2005 US) in Liberia and Earning from trade(constant 2005 US) in Ukraine?
Offer a very short reply. -4.53e+1. In the year 2006, what is the difference between the Earning from trade(constant 2005 US) of Trinidad and Tobago and Earning from trade(constant 2005 US) of Ukraine?
Make the answer very short. -4.06e+1. In the year 2007, what is the difference between the Earning from trade(constant 2005 US) of Liberia and Earning from trade(constant 2005 US) of Trinidad and Tobago?
Your answer should be very brief. -5.94e+09. In the year 2007, what is the difference between the Earning from trade(constant 2005 US) in Liberia and Earning from trade(constant 2005 US) in Ukraine?
Your answer should be very brief. -5.46e+1. In the year 2007, what is the difference between the Earning from trade(constant 2005 US) of Trinidad and Tobago and Earning from trade(constant 2005 US) of Ukraine?
Give a very brief answer. -4.87e+1. In the year 2008, what is the difference between the Earning from trade(constant 2005 US) of Liberia and Earning from trade(constant 2005 US) of Trinidad and Tobago?
Give a very brief answer. -7.10e+09. In the year 2008, what is the difference between the Earning from trade(constant 2005 US) in Liberia and Earning from trade(constant 2005 US) in Ukraine?
Give a very brief answer. -6.41e+1. In the year 2008, what is the difference between the Earning from trade(constant 2005 US) in Trinidad and Tobago and Earning from trade(constant 2005 US) in Ukraine?
Give a very brief answer. -5.70e+1. In the year 2009, what is the difference between the Earning from trade(constant 2005 US) in Liberia and Earning from trade(constant 2005 US) in Trinidad and Tobago?
Your answer should be compact. -5.27e+09. In the year 2009, what is the difference between the Earning from trade(constant 2005 US) in Liberia and Earning from trade(constant 2005 US) in Ukraine?
Make the answer very short. -3.86e+1. In the year 2009, what is the difference between the Earning from trade(constant 2005 US) in Trinidad and Tobago and Earning from trade(constant 2005 US) in Ukraine?
Your answer should be very brief. -3.33e+1. What is the ratio of the Earning from trade(constant 2005 US) of Liberia in 2002 to that in 2003?
Your answer should be very brief. 1.23. What is the ratio of the Earning from trade(constant 2005 US) in Trinidad and Tobago in 2002 to that in 2003?
Offer a terse response. 0.69. What is the ratio of the Earning from trade(constant 2005 US) of Ukraine in 2002 to that in 2003?
Offer a terse response. 0.97. What is the ratio of the Earning from trade(constant 2005 US) of Liberia in 2002 to that in 2004?
Provide a succinct answer. 1.17. What is the ratio of the Earning from trade(constant 2005 US) of Trinidad and Tobago in 2002 to that in 2004?
Your answer should be very brief. 0.67. What is the ratio of the Earning from trade(constant 2005 US) in Ukraine in 2002 to that in 2004?
Ensure brevity in your answer.  0.84. What is the ratio of the Earning from trade(constant 2005 US) of Liberia in 2002 to that in 2005?
Provide a short and direct response. 1.09. What is the ratio of the Earning from trade(constant 2005 US) in Trinidad and Tobago in 2002 to that in 2005?
Provide a short and direct response. 0.65. What is the ratio of the Earning from trade(constant 2005 US) in Ukraine in 2002 to that in 2005?
Make the answer very short. 0.82. What is the ratio of the Earning from trade(constant 2005 US) of Liberia in 2002 to that in 2006?
Give a very brief answer. 1.02. What is the ratio of the Earning from trade(constant 2005 US) in Trinidad and Tobago in 2002 to that in 2006?
Keep it short and to the point. 0.68. What is the ratio of the Earning from trade(constant 2005 US) in Ukraine in 2002 to that in 2006?
Your answer should be compact. 0.77. What is the ratio of the Earning from trade(constant 2005 US) of Trinidad and Tobago in 2002 to that in 2007?
Your response must be concise. 0.57. What is the ratio of the Earning from trade(constant 2005 US) of Ukraine in 2002 to that in 2007?
Offer a very short reply. 0.64. What is the ratio of the Earning from trade(constant 2005 US) of Liberia in 2002 to that in 2008?
Give a very brief answer. 1. What is the ratio of the Earning from trade(constant 2005 US) in Trinidad and Tobago in 2002 to that in 2008?
Your answer should be very brief. 0.49. What is the ratio of the Earning from trade(constant 2005 US) of Ukraine in 2002 to that in 2008?
Give a very brief answer. 0.55. What is the ratio of the Earning from trade(constant 2005 US) in Liberia in 2002 to that in 2009?
Offer a terse response. 0.96. What is the ratio of the Earning from trade(constant 2005 US) of Trinidad and Tobago in 2002 to that in 2009?
Give a very brief answer. 0.62. What is the ratio of the Earning from trade(constant 2005 US) of Ukraine in 2002 to that in 2009?
Provide a short and direct response. 0.9. What is the ratio of the Earning from trade(constant 2005 US) in Liberia in 2003 to that in 2004?
Give a very brief answer. 0.95. What is the ratio of the Earning from trade(constant 2005 US) of Trinidad and Tobago in 2003 to that in 2004?
Provide a short and direct response. 0.98. What is the ratio of the Earning from trade(constant 2005 US) in Ukraine in 2003 to that in 2004?
Ensure brevity in your answer.  0.87. What is the ratio of the Earning from trade(constant 2005 US) of Liberia in 2003 to that in 2005?
Provide a short and direct response. 0.89. What is the ratio of the Earning from trade(constant 2005 US) of Trinidad and Tobago in 2003 to that in 2005?
Offer a terse response. 0.95. What is the ratio of the Earning from trade(constant 2005 US) in Ukraine in 2003 to that in 2005?
Offer a very short reply. 0.85. What is the ratio of the Earning from trade(constant 2005 US) in Liberia in 2003 to that in 2006?
Make the answer very short. 0.83. What is the ratio of the Earning from trade(constant 2005 US) in Trinidad and Tobago in 2003 to that in 2006?
Make the answer very short. 0.99. What is the ratio of the Earning from trade(constant 2005 US) of Ukraine in 2003 to that in 2006?
Give a very brief answer. 0.79. What is the ratio of the Earning from trade(constant 2005 US) in Liberia in 2003 to that in 2007?
Ensure brevity in your answer.  0.82. What is the ratio of the Earning from trade(constant 2005 US) in Trinidad and Tobago in 2003 to that in 2007?
Keep it short and to the point. 0.83. What is the ratio of the Earning from trade(constant 2005 US) in Ukraine in 2003 to that in 2007?
Make the answer very short. 0.66. What is the ratio of the Earning from trade(constant 2005 US) in Liberia in 2003 to that in 2008?
Ensure brevity in your answer.  0.81. What is the ratio of the Earning from trade(constant 2005 US) in Trinidad and Tobago in 2003 to that in 2008?
Your response must be concise. 0.71. What is the ratio of the Earning from trade(constant 2005 US) in Ukraine in 2003 to that in 2008?
Your answer should be compact. 0.57. What is the ratio of the Earning from trade(constant 2005 US) of Liberia in 2003 to that in 2009?
Offer a terse response. 0.78. What is the ratio of the Earning from trade(constant 2005 US) of Trinidad and Tobago in 2003 to that in 2009?
Offer a terse response. 0.9. What is the ratio of the Earning from trade(constant 2005 US) in Ukraine in 2003 to that in 2009?
Your answer should be very brief. 0.93. What is the ratio of the Earning from trade(constant 2005 US) in Liberia in 2004 to that in 2005?
Ensure brevity in your answer.  0.94. What is the ratio of the Earning from trade(constant 2005 US) in Trinidad and Tobago in 2004 to that in 2005?
Your answer should be compact. 0.97. What is the ratio of the Earning from trade(constant 2005 US) in Ukraine in 2004 to that in 2005?
Keep it short and to the point. 0.98. What is the ratio of the Earning from trade(constant 2005 US) of Liberia in 2004 to that in 2006?
Your response must be concise. 0.87. What is the ratio of the Earning from trade(constant 2005 US) of Trinidad and Tobago in 2004 to that in 2006?
Provide a short and direct response. 1.02. What is the ratio of the Earning from trade(constant 2005 US) in Ukraine in 2004 to that in 2006?
Your answer should be compact. 0.92. What is the ratio of the Earning from trade(constant 2005 US) of Liberia in 2004 to that in 2007?
Offer a terse response. 0.86. What is the ratio of the Earning from trade(constant 2005 US) of Trinidad and Tobago in 2004 to that in 2007?
Keep it short and to the point. 0.85. What is the ratio of the Earning from trade(constant 2005 US) in Ukraine in 2004 to that in 2007?
Make the answer very short. 0.76. What is the ratio of the Earning from trade(constant 2005 US) in Liberia in 2004 to that in 2008?
Your answer should be very brief. 0.86. What is the ratio of the Earning from trade(constant 2005 US) of Trinidad and Tobago in 2004 to that in 2008?
Ensure brevity in your answer.  0.73. What is the ratio of the Earning from trade(constant 2005 US) of Ukraine in 2004 to that in 2008?
Ensure brevity in your answer.  0.65. What is the ratio of the Earning from trade(constant 2005 US) in Liberia in 2004 to that in 2009?
Offer a terse response. 0.82. What is the ratio of the Earning from trade(constant 2005 US) in Trinidad and Tobago in 2004 to that in 2009?
Keep it short and to the point. 0.93. What is the ratio of the Earning from trade(constant 2005 US) in Ukraine in 2004 to that in 2009?
Ensure brevity in your answer.  1.07. What is the ratio of the Earning from trade(constant 2005 US) in Liberia in 2005 to that in 2006?
Provide a succinct answer. 0.93. What is the ratio of the Earning from trade(constant 2005 US) of Trinidad and Tobago in 2005 to that in 2006?
Your answer should be very brief. 1.05. What is the ratio of the Earning from trade(constant 2005 US) in Ukraine in 2005 to that in 2006?
Offer a very short reply. 0.94. What is the ratio of the Earning from trade(constant 2005 US) of Liberia in 2005 to that in 2007?
Your response must be concise. 0.92. What is the ratio of the Earning from trade(constant 2005 US) in Trinidad and Tobago in 2005 to that in 2007?
Your answer should be compact. 0.87. What is the ratio of the Earning from trade(constant 2005 US) of Ukraine in 2005 to that in 2007?
Ensure brevity in your answer.  0.78. What is the ratio of the Earning from trade(constant 2005 US) in Liberia in 2005 to that in 2008?
Make the answer very short. 0.92. What is the ratio of the Earning from trade(constant 2005 US) in Trinidad and Tobago in 2005 to that in 2008?
Your answer should be very brief. 0.75. What is the ratio of the Earning from trade(constant 2005 US) of Ukraine in 2005 to that in 2008?
Your response must be concise. 0.67. What is the ratio of the Earning from trade(constant 2005 US) of Liberia in 2005 to that in 2009?
Provide a short and direct response. 0.88. What is the ratio of the Earning from trade(constant 2005 US) in Trinidad and Tobago in 2005 to that in 2009?
Make the answer very short. 0.95. What is the ratio of the Earning from trade(constant 2005 US) of Ukraine in 2005 to that in 2009?
Your answer should be very brief. 1.09. What is the ratio of the Earning from trade(constant 2005 US) in Trinidad and Tobago in 2006 to that in 2007?
Provide a short and direct response. 0.83. What is the ratio of the Earning from trade(constant 2005 US) of Ukraine in 2006 to that in 2007?
Ensure brevity in your answer.  0.83. What is the ratio of the Earning from trade(constant 2005 US) of Liberia in 2006 to that in 2008?
Make the answer very short. 0.99. What is the ratio of the Earning from trade(constant 2005 US) in Trinidad and Tobago in 2006 to that in 2008?
Your response must be concise. 0.72. What is the ratio of the Earning from trade(constant 2005 US) in Ukraine in 2006 to that in 2008?
Your answer should be very brief. 0.71. What is the ratio of the Earning from trade(constant 2005 US) in Liberia in 2006 to that in 2009?
Your answer should be compact. 0.95. What is the ratio of the Earning from trade(constant 2005 US) of Trinidad and Tobago in 2006 to that in 2009?
Offer a terse response. 0.91. What is the ratio of the Earning from trade(constant 2005 US) of Ukraine in 2006 to that in 2009?
Provide a short and direct response. 1.17. What is the ratio of the Earning from trade(constant 2005 US) in Liberia in 2007 to that in 2008?
Your answer should be compact. 1. What is the ratio of the Earning from trade(constant 2005 US) of Trinidad and Tobago in 2007 to that in 2008?
Your answer should be very brief. 0.86. What is the ratio of the Earning from trade(constant 2005 US) of Ukraine in 2007 to that in 2008?
Your answer should be compact. 0.85. What is the ratio of the Earning from trade(constant 2005 US) in Liberia in 2007 to that in 2009?
Provide a succinct answer. 0.96. What is the ratio of the Earning from trade(constant 2005 US) of Trinidad and Tobago in 2007 to that in 2009?
Your answer should be very brief. 1.09. What is the ratio of the Earning from trade(constant 2005 US) in Ukraine in 2007 to that in 2009?
Provide a succinct answer. 1.4. What is the ratio of the Earning from trade(constant 2005 US) in Liberia in 2008 to that in 2009?
Your answer should be very brief. 0.96. What is the ratio of the Earning from trade(constant 2005 US) in Trinidad and Tobago in 2008 to that in 2009?
Your answer should be very brief. 1.27. What is the ratio of the Earning from trade(constant 2005 US) in Ukraine in 2008 to that in 2009?
Keep it short and to the point. 1.64. What is the difference between the highest and the second highest Earning from trade(constant 2005 US) in Liberia?
Provide a succinct answer. 5.17e+07. What is the difference between the highest and the second highest Earning from trade(constant 2005 US) in Trinidad and Tobago?
Offer a terse response. 1.17e+09. What is the difference between the highest and the second highest Earning from trade(constant 2005 US) in Ukraine?
Give a very brief answer. 9.50e+09. What is the difference between the highest and the lowest Earning from trade(constant 2005 US) of Liberia?
Provide a short and direct response. 2.88e+08. What is the difference between the highest and the lowest Earning from trade(constant 2005 US) in Trinidad and Tobago?
Provide a short and direct response. 4.28e+09. What is the difference between the highest and the lowest Earning from trade(constant 2005 US) in Ukraine?
Offer a terse response. 2.95e+1. 